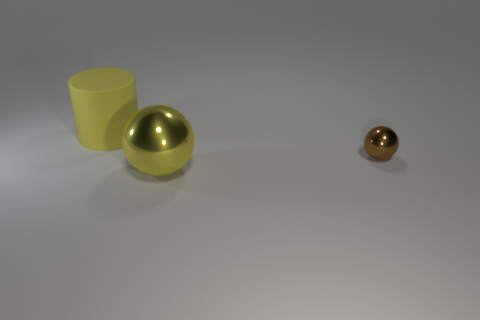There is a large object that is the same color as the big ball; what is its material?
Your response must be concise. Rubber. Is there another big metal object that has the same shape as the brown thing?
Your answer should be very brief. Yes. Is the color of the big rubber thing the same as the big object in front of the large matte cylinder?
Offer a terse response. Yes. Is there a brown metal thing of the same size as the cylinder?
Offer a very short reply. No. Do the large yellow ball and the object that is behind the small brown shiny thing have the same material?
Give a very brief answer. No. Are there more large yellow matte cylinders than big brown metallic cylinders?
Offer a very short reply. Yes. How many balls are tiny brown objects or yellow things?
Your answer should be very brief. 2. The large rubber thing has what color?
Offer a terse response. Yellow. There is a ball in front of the tiny shiny sphere; is it the same size as the metal object that is right of the big yellow metallic object?
Your answer should be very brief. No. Is the number of large yellow cylinders less than the number of big gray metallic spheres?
Provide a succinct answer. No. 